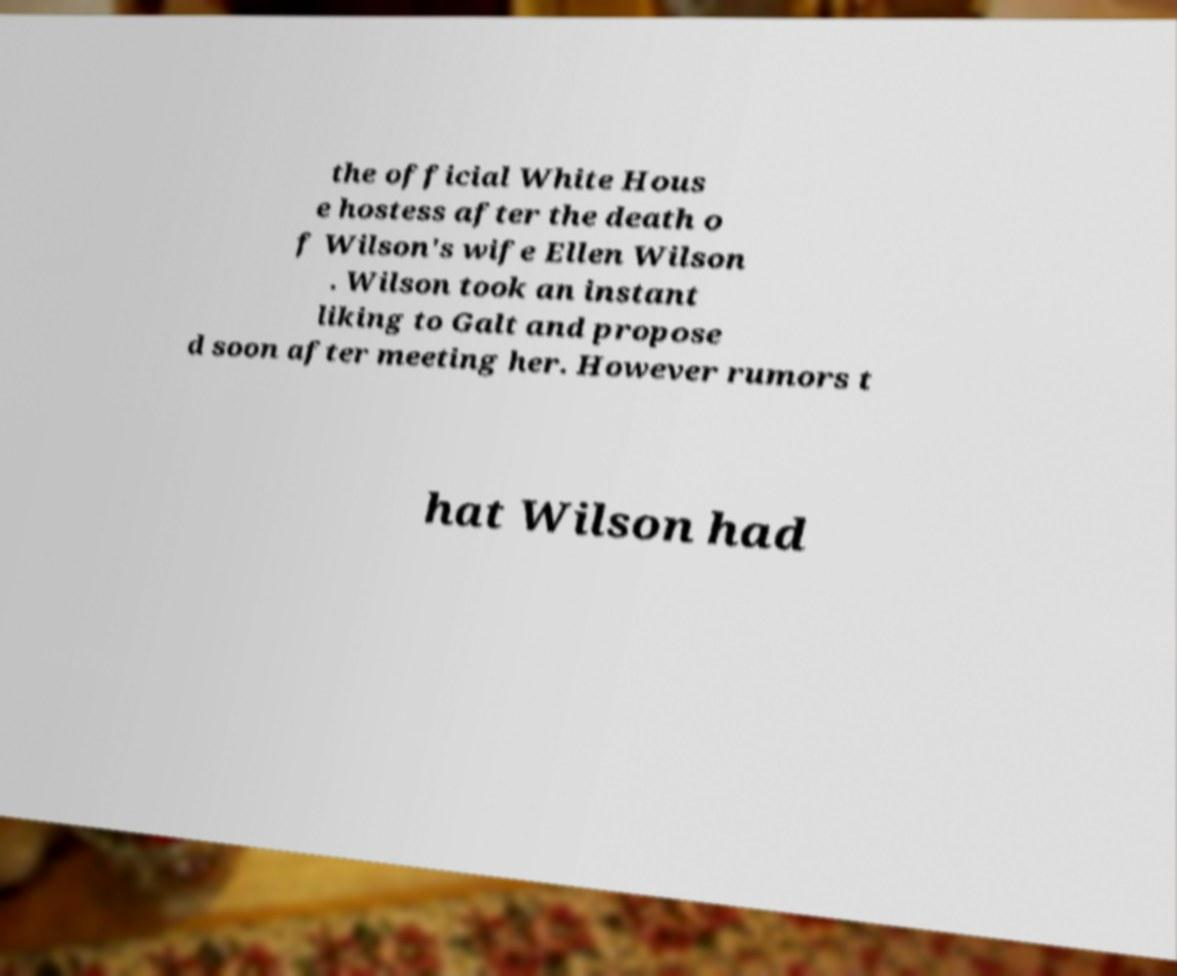Please identify and transcribe the text found in this image. the official White Hous e hostess after the death o f Wilson's wife Ellen Wilson . Wilson took an instant liking to Galt and propose d soon after meeting her. However rumors t hat Wilson had 